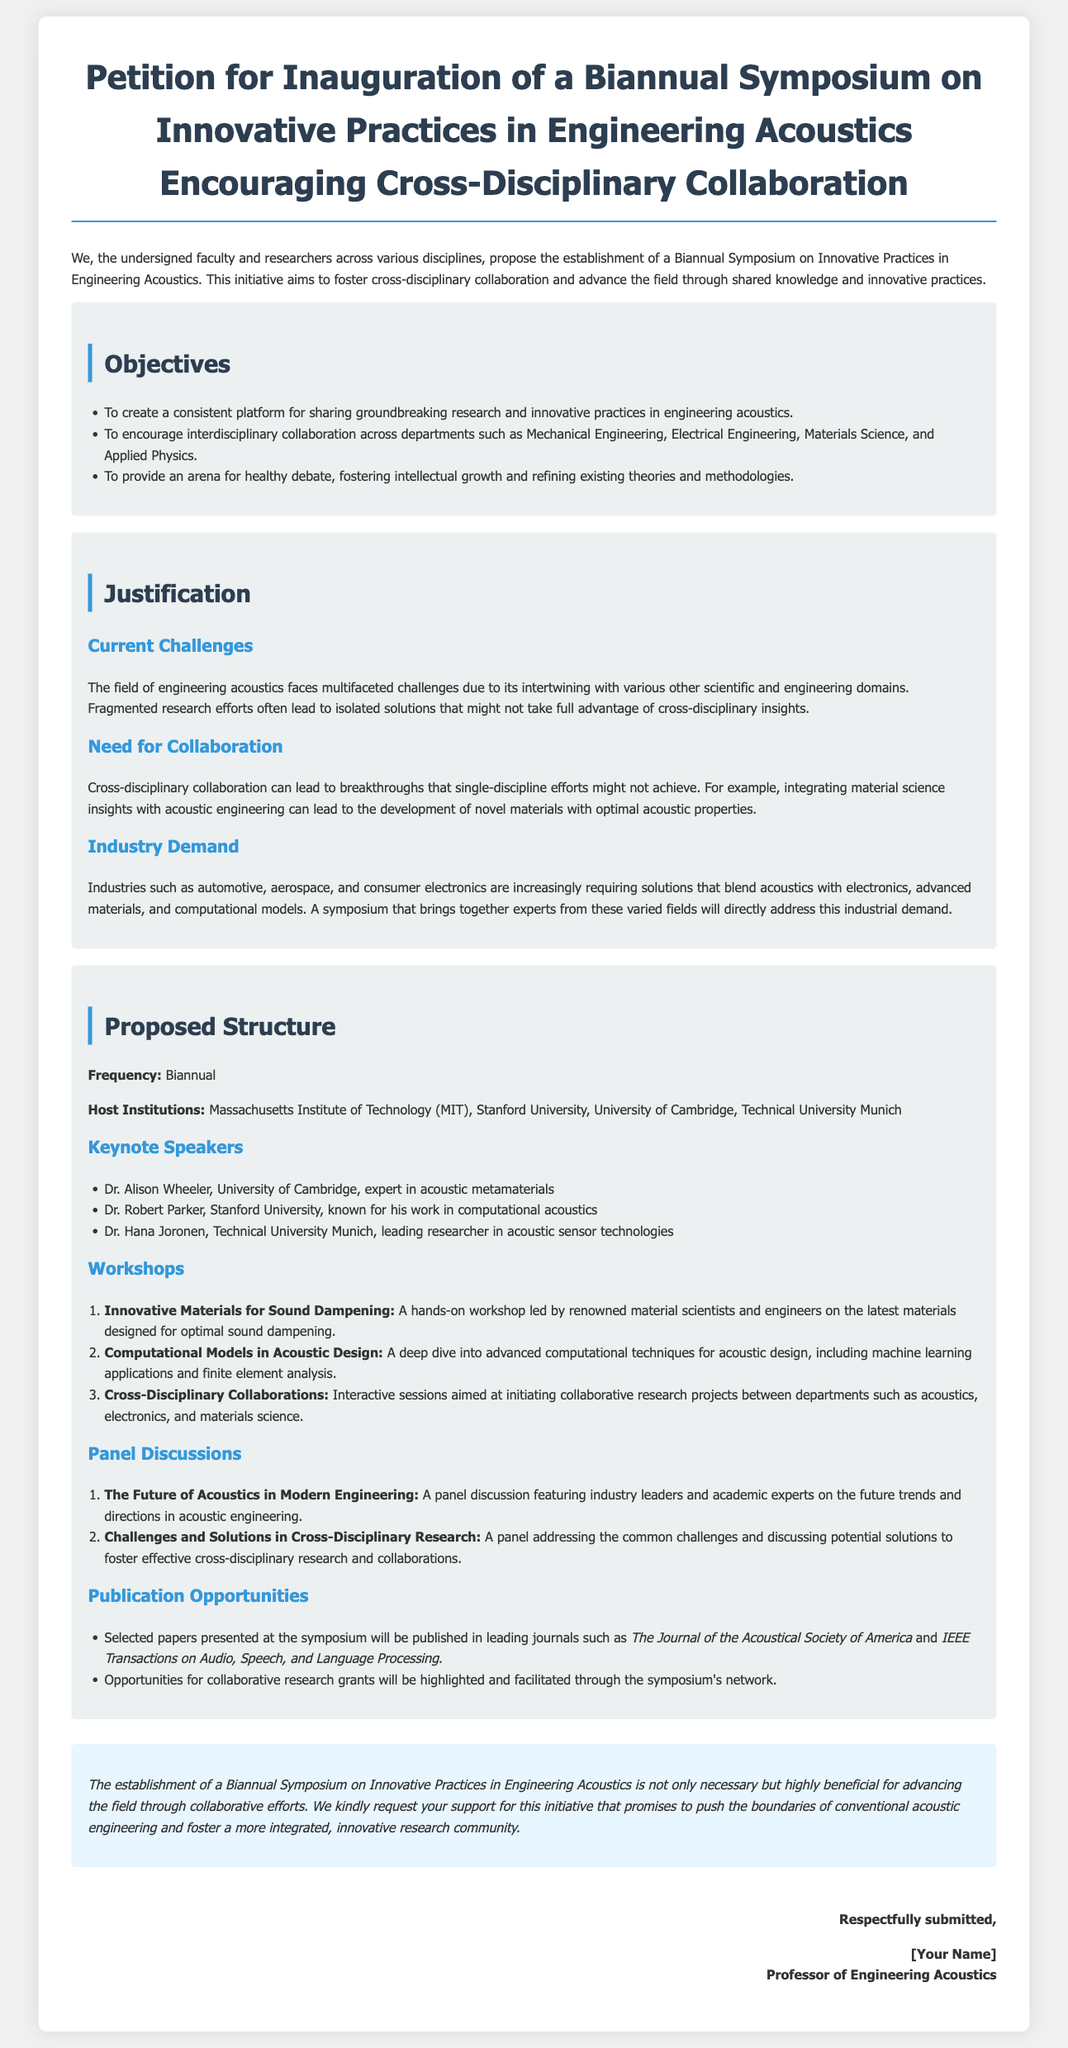What is the title of the petition? The title is prominently displayed at the beginning of the document.
Answer: Petition for Inauguration of a Biannual Symposium on Innovative Practices in Engineering Acoustics Encouraging Cross-Disciplinary Collaboration Who are the proposed host institutions? The institutions are mentioned in the proposed structure section of the document.
Answer: Massachusetts Institute of Technology, Stanford University, University of Cambridge, Technical University Munich How often is the symposium proposed to be held? The frequency is clearly stated in the proposed structure section.
Answer: Biannual What is one of the objectives of the symposium? This information is found in the objectives section, highlighting the main goals of the initiative.
Answer: To create a consistent platform for sharing groundbreaking research and innovative practices in engineering acoustics Who is one of the keynote speakers? The names of the keynote speakers are listed in the proposed structure section.
Answer: Dr. Alison Wheeler What is a challenge mentioned in the justification section? The challenges faced in the field are outlined in the justification section.
Answer: Fragmented research efforts What is one of the workshop topics proposed? The specific workshops are mentioned under the proposed structure section with their focus areas.
Answer: Innovative Materials for Sound Dampening What publication opportunities are mentioned? The publication opportunities for selected papers are discussed in the proposed structure section.
Answer: Selected papers presented at the symposium will be published in leading journals such as The Journal of the Acoustical Society of America and IEEE Transactions on Audio, Speech, and Language Processing What is the concluding request of the petition? The conclusion summarizes the petition's request for support in establishing the symposium.
Answer: We kindly request your support for this initiative 